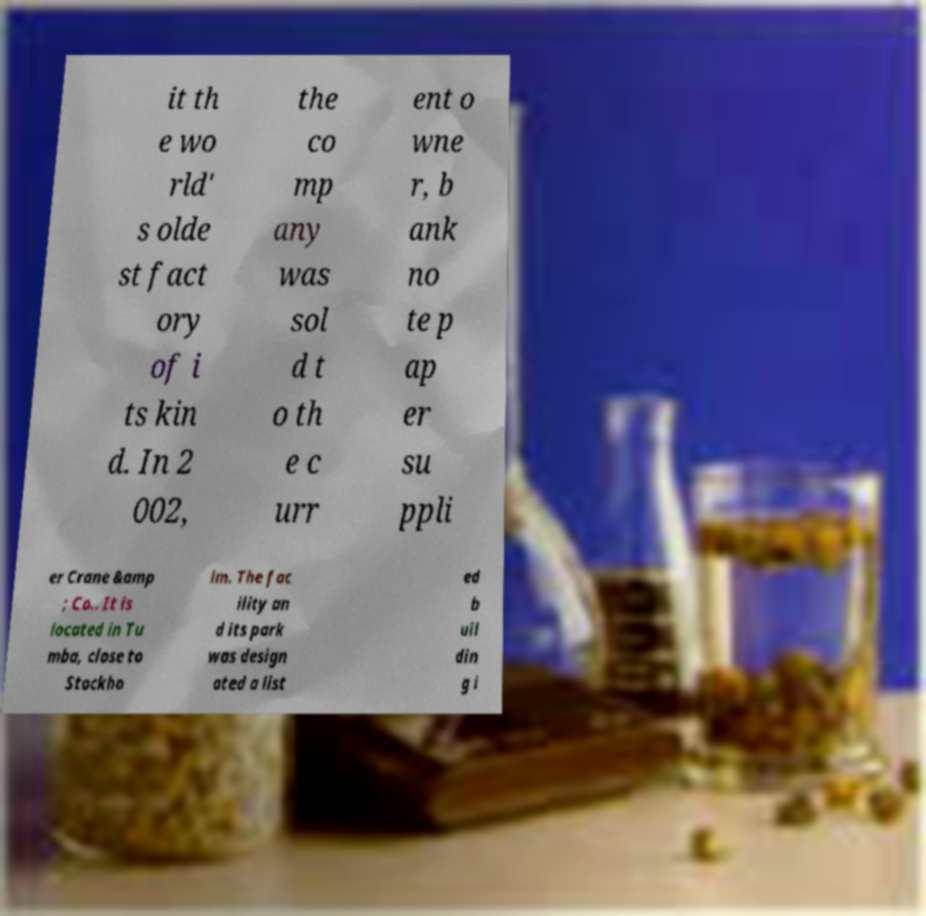Can you read and provide the text displayed in the image?This photo seems to have some interesting text. Can you extract and type it out for me? it th e wo rld' s olde st fact ory of i ts kin d. In 2 002, the co mp any was sol d t o th e c urr ent o wne r, b ank no te p ap er su ppli er Crane &amp ; Co.. It is located in Tu mba, close to Stockho lm. The fac ility an d its park was design ated a list ed b uil din g i 